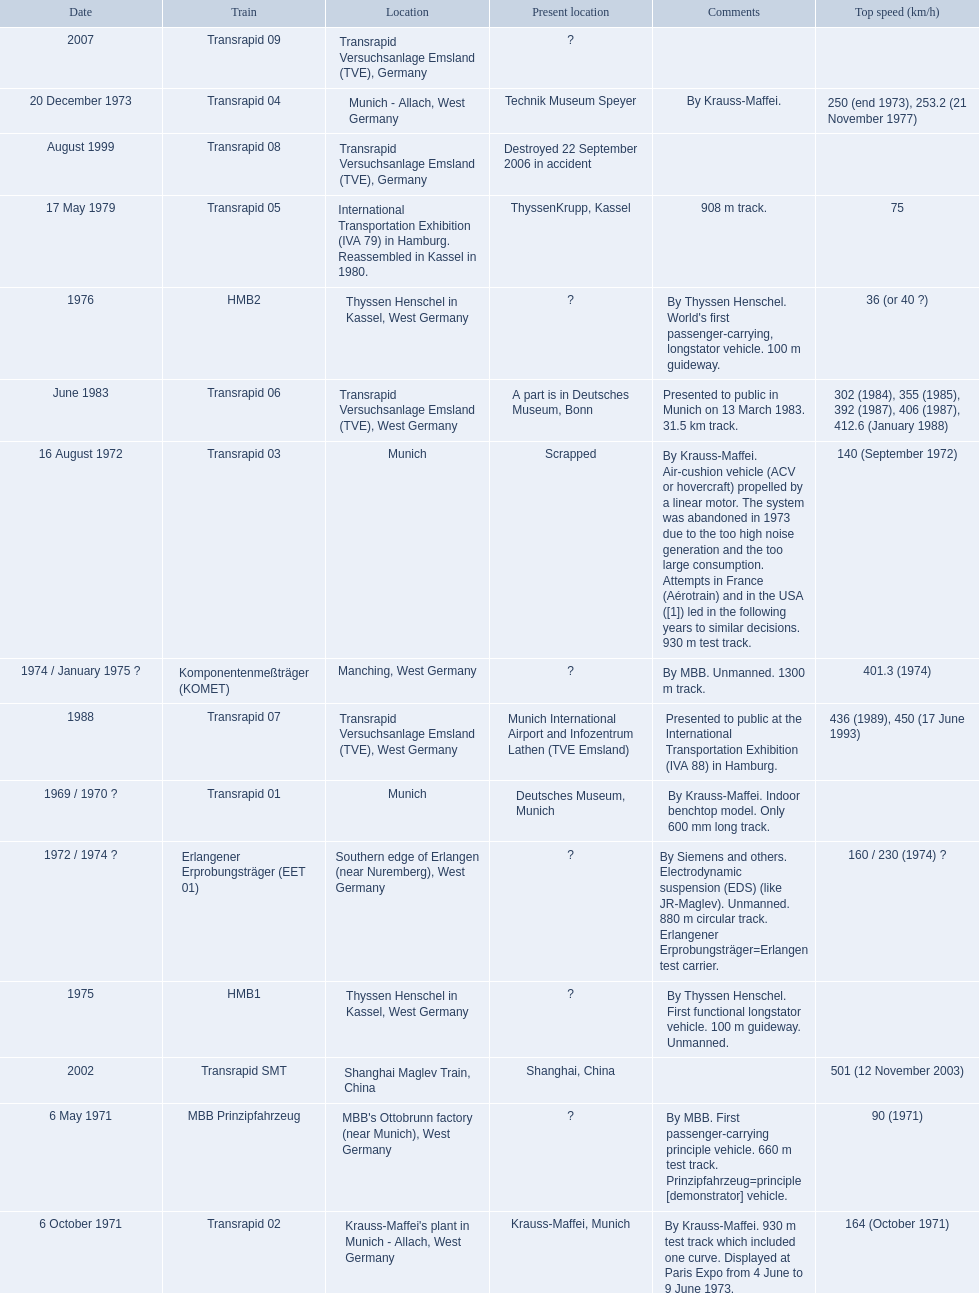Which trains exceeded a top speed of 400+? Komponentenmeßträger (KOMET), Transrapid 07, Transrapid SMT. How about 500+? Transrapid SMT. 